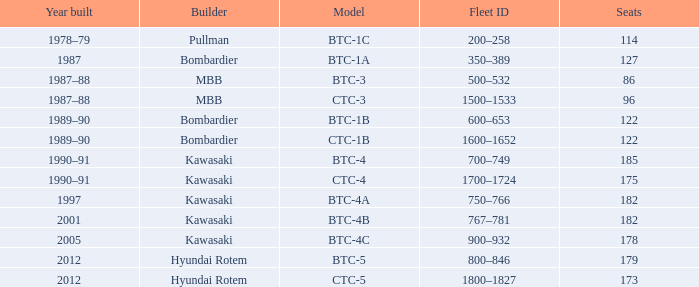What is the year of production for the ctc-3 model? 1987–88. 